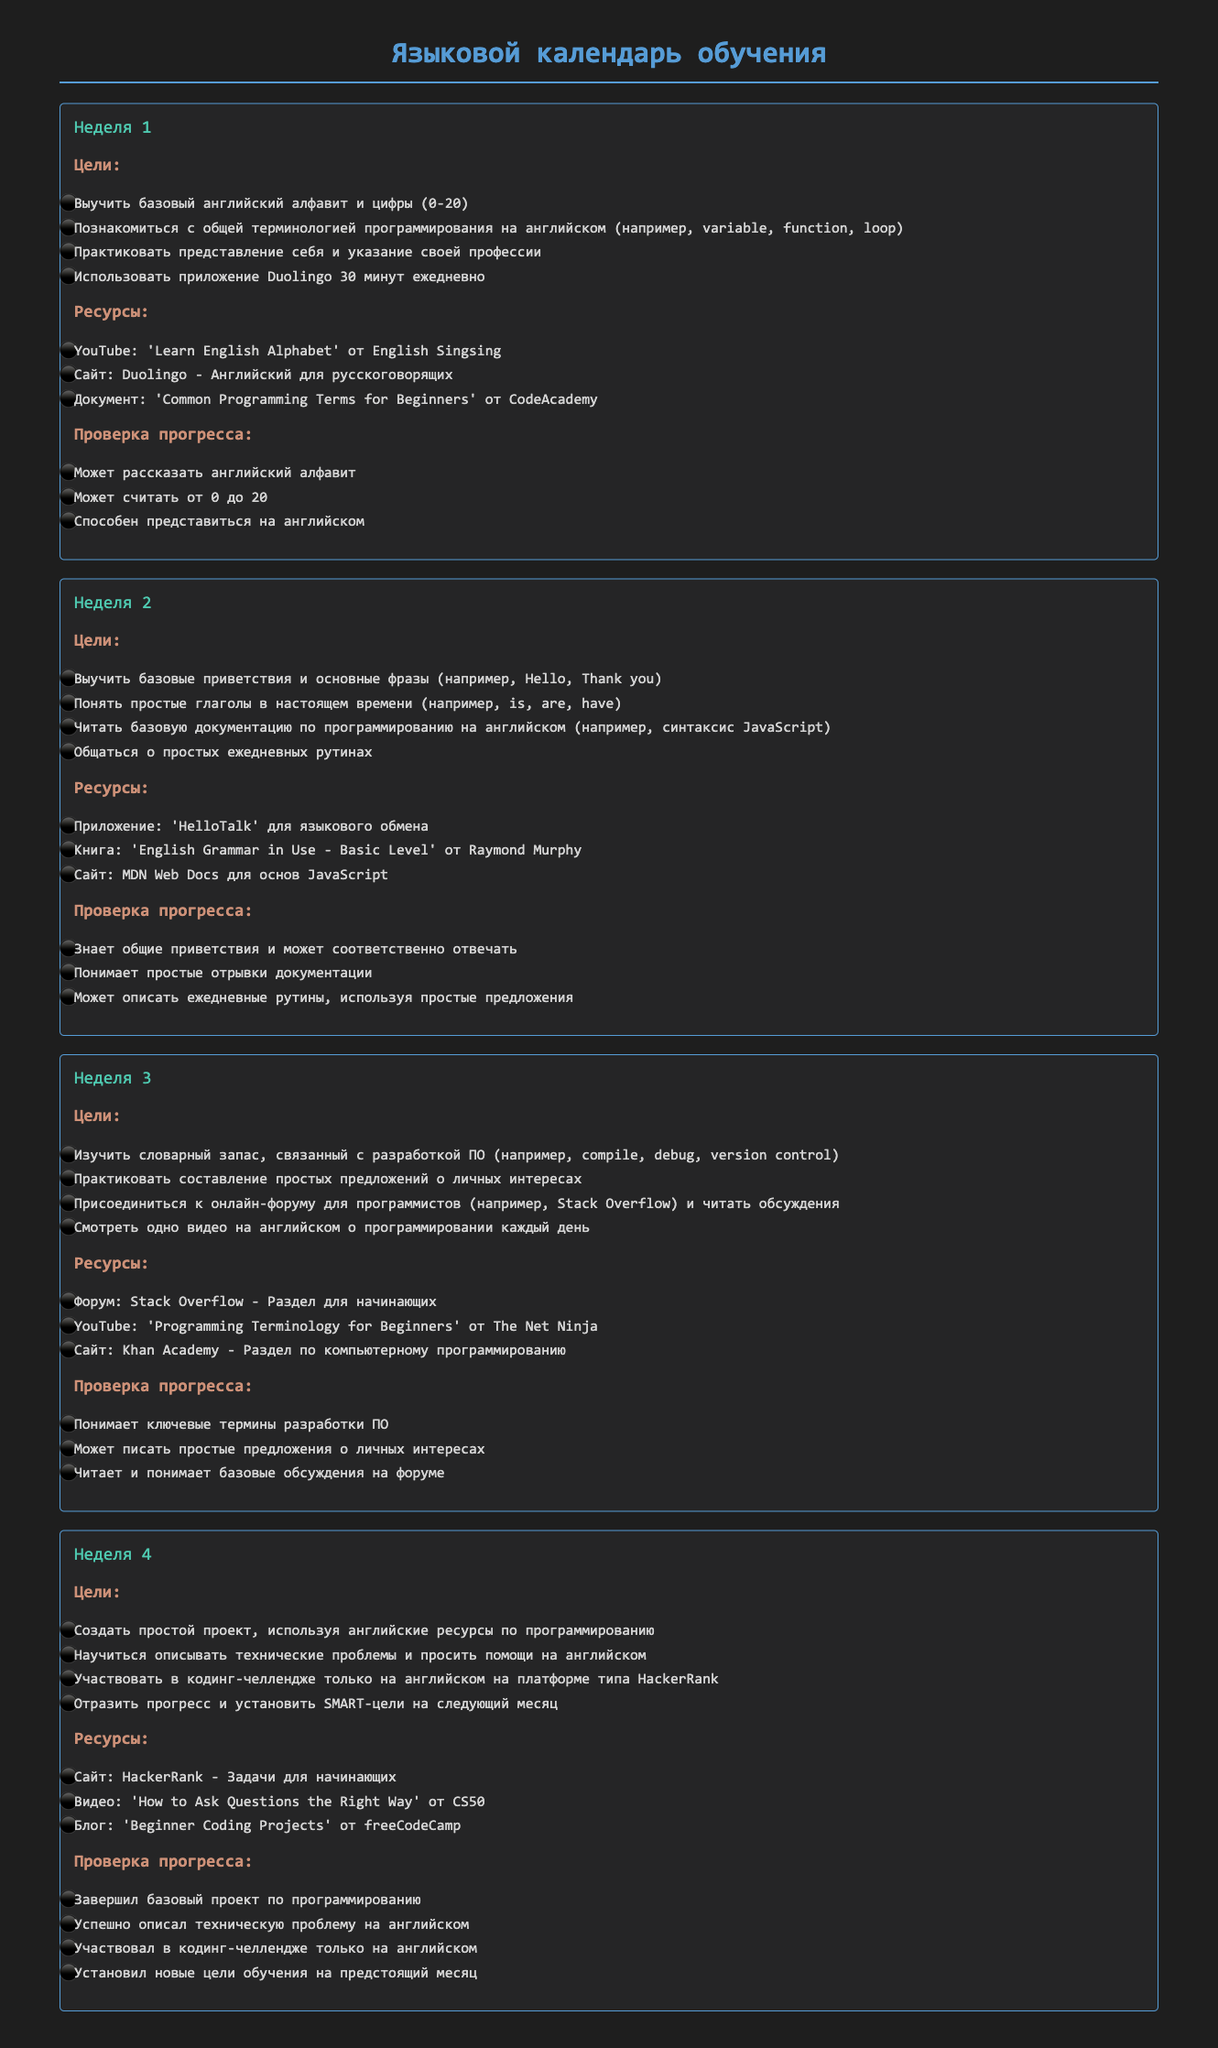Какова цель на первую неделю? Цель на первую неделю указана в разделе "Цели" для "Неделя 1", которая включает изучение базового английского алфавита и цифр.
Answer: Выучить базовый английский алфавит и цифры (0-20) Какие ресурсы используются на вторую неделю? Ресурсы указаны в разделе "Ресурсы" для "Неделя 2", включает в себя приложение и книгу.
Answer: Приложение: 'HelloTalk' для языкового обмена Сколько времени нужно использовать Duolingo в первую неделю? В документе указано количество времени, необходимое для использования приложения Duolingo в первой неделе.
Answer: 30 минут ежедневно Какой прогресс должен быть достигнут к концу третьей недели? Прогресс с третьей недели описан в разделе "Проверка прогресса" и включает понимание ключевых терминов.
Answer: Понимает ключевые термины разработки ПО Сколько целей указано для четвертой недели? Количество целей указано в разделе "Цели" для "Неделя 4".
Answer: 4 